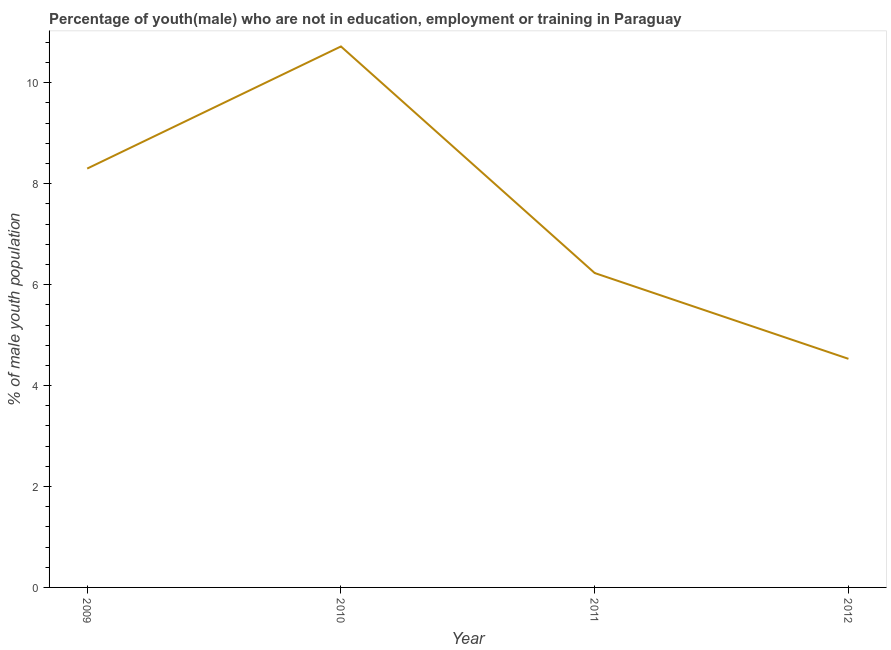What is the unemployed male youth population in 2010?
Give a very brief answer. 10.72. Across all years, what is the maximum unemployed male youth population?
Your response must be concise. 10.72. Across all years, what is the minimum unemployed male youth population?
Your answer should be compact. 4.53. What is the sum of the unemployed male youth population?
Ensure brevity in your answer.  29.78. What is the difference between the unemployed male youth population in 2010 and 2011?
Give a very brief answer. 4.49. What is the average unemployed male youth population per year?
Your answer should be compact. 7.45. What is the median unemployed male youth population?
Make the answer very short. 7.27. In how many years, is the unemployed male youth population greater than 10 %?
Provide a succinct answer. 1. What is the ratio of the unemployed male youth population in 2009 to that in 2010?
Keep it short and to the point. 0.77. What is the difference between the highest and the second highest unemployed male youth population?
Offer a very short reply. 2.42. What is the difference between the highest and the lowest unemployed male youth population?
Provide a short and direct response. 6.19. Does the unemployed male youth population monotonically increase over the years?
Offer a terse response. No. How many lines are there?
Give a very brief answer. 1. How many years are there in the graph?
Your answer should be very brief. 4. Are the values on the major ticks of Y-axis written in scientific E-notation?
Your response must be concise. No. Does the graph contain any zero values?
Provide a succinct answer. No. Does the graph contain grids?
Your response must be concise. No. What is the title of the graph?
Give a very brief answer. Percentage of youth(male) who are not in education, employment or training in Paraguay. What is the label or title of the X-axis?
Offer a very short reply. Year. What is the label or title of the Y-axis?
Your answer should be compact. % of male youth population. What is the % of male youth population in 2009?
Provide a short and direct response. 8.3. What is the % of male youth population of 2010?
Make the answer very short. 10.72. What is the % of male youth population of 2011?
Your response must be concise. 6.23. What is the % of male youth population in 2012?
Offer a terse response. 4.53. What is the difference between the % of male youth population in 2009 and 2010?
Keep it short and to the point. -2.42. What is the difference between the % of male youth population in 2009 and 2011?
Your answer should be compact. 2.07. What is the difference between the % of male youth population in 2009 and 2012?
Offer a very short reply. 3.77. What is the difference between the % of male youth population in 2010 and 2011?
Make the answer very short. 4.49. What is the difference between the % of male youth population in 2010 and 2012?
Ensure brevity in your answer.  6.19. What is the ratio of the % of male youth population in 2009 to that in 2010?
Keep it short and to the point. 0.77. What is the ratio of the % of male youth population in 2009 to that in 2011?
Give a very brief answer. 1.33. What is the ratio of the % of male youth population in 2009 to that in 2012?
Your answer should be very brief. 1.83. What is the ratio of the % of male youth population in 2010 to that in 2011?
Your answer should be compact. 1.72. What is the ratio of the % of male youth population in 2010 to that in 2012?
Provide a short and direct response. 2.37. What is the ratio of the % of male youth population in 2011 to that in 2012?
Make the answer very short. 1.38. 